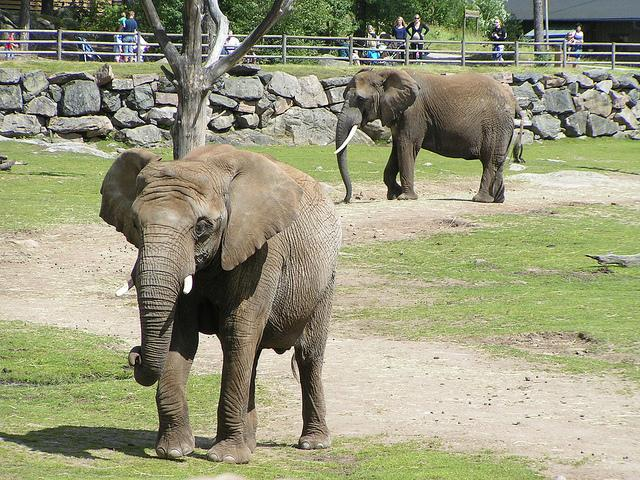At which elevation are the elephants compared to those looking at them? lower 